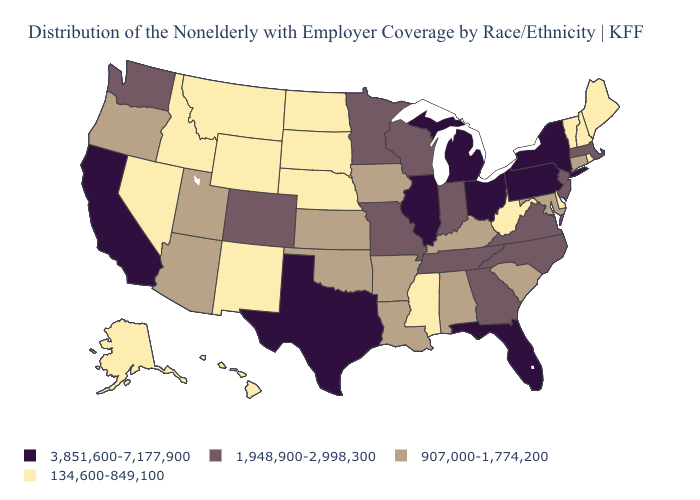Does Florida have the highest value in the South?
Be succinct. Yes. What is the value of Nevada?
Concise answer only. 134,600-849,100. Among the states that border Rhode Island , which have the highest value?
Write a very short answer. Massachusetts. What is the value of Ohio?
Concise answer only. 3,851,600-7,177,900. What is the lowest value in the USA?
Short answer required. 134,600-849,100. Name the states that have a value in the range 134,600-849,100?
Write a very short answer. Alaska, Delaware, Hawaii, Idaho, Maine, Mississippi, Montana, Nebraska, Nevada, New Hampshire, New Mexico, North Dakota, Rhode Island, South Dakota, Vermont, West Virginia, Wyoming. Name the states that have a value in the range 907,000-1,774,200?
Quick response, please. Alabama, Arizona, Arkansas, Connecticut, Iowa, Kansas, Kentucky, Louisiana, Maryland, Oklahoma, Oregon, South Carolina, Utah. Is the legend a continuous bar?
Be succinct. No. Name the states that have a value in the range 1,948,900-2,998,300?
Short answer required. Colorado, Georgia, Indiana, Massachusetts, Minnesota, Missouri, New Jersey, North Carolina, Tennessee, Virginia, Washington, Wisconsin. Among the states that border Florida , does Georgia have the highest value?
Short answer required. Yes. Does the map have missing data?
Write a very short answer. No. Does Missouri have the lowest value in the USA?
Short answer required. No. Which states have the lowest value in the USA?
Be succinct. Alaska, Delaware, Hawaii, Idaho, Maine, Mississippi, Montana, Nebraska, Nevada, New Hampshire, New Mexico, North Dakota, Rhode Island, South Dakota, Vermont, West Virginia, Wyoming. Does Delaware have the lowest value in the USA?
Quick response, please. Yes. What is the lowest value in the MidWest?
Quick response, please. 134,600-849,100. 